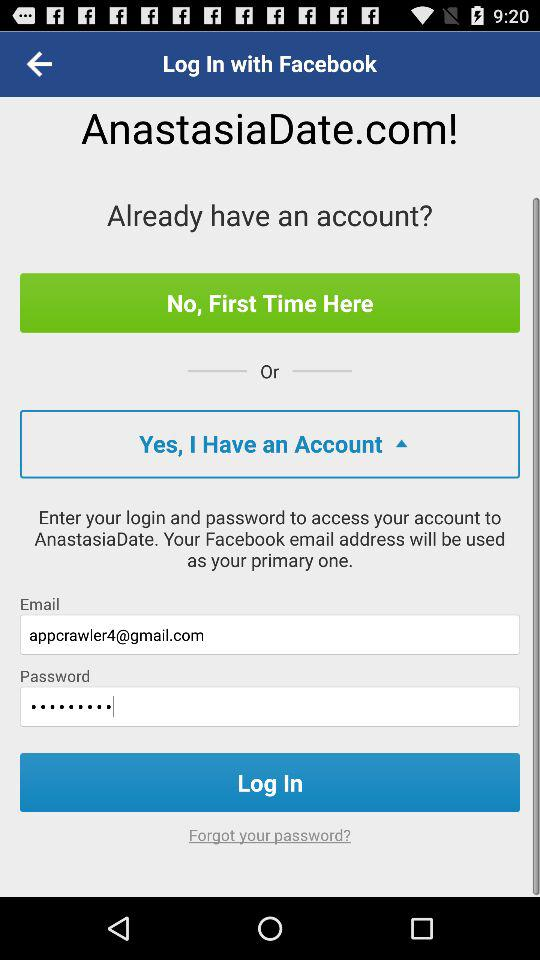How many characters are required to create a password?
When the provided information is insufficient, respond with <no answer>. <no answer> 